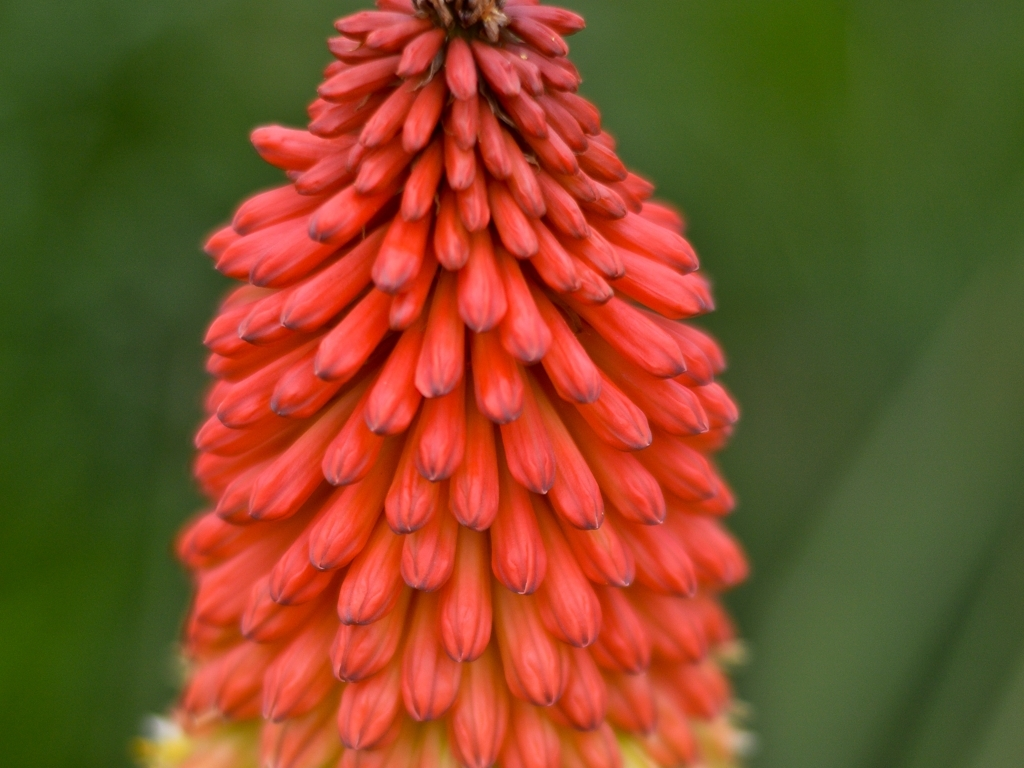Are there any quality issues with this image? Yes, the image exhibits a shallow depth of field, with only a portion of the red flower petals in sharp focus while the green background and peripheral petals are blurred, which could be an artistic choice but may also be seen as a quality issue depending on the intended use. 